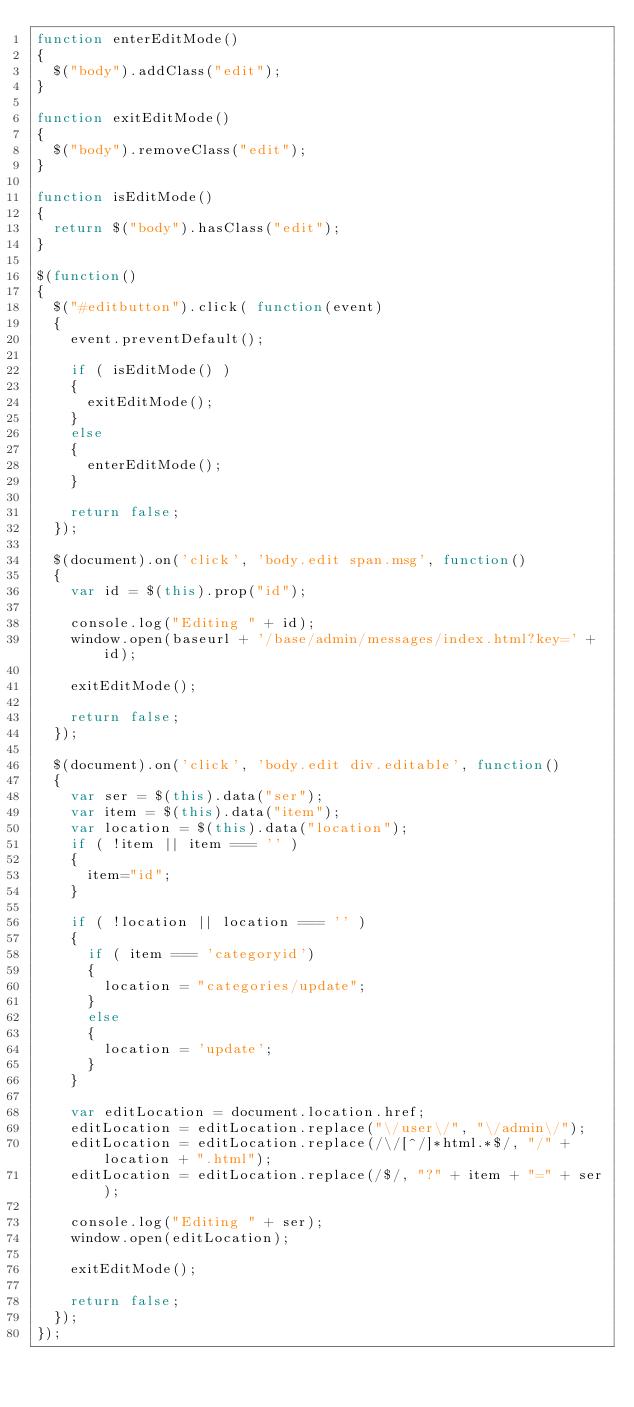<code> <loc_0><loc_0><loc_500><loc_500><_JavaScript_>function enterEditMode()
{
	$("body").addClass("edit");
}

function exitEditMode()
{
	$("body").removeClass("edit");
}

function isEditMode()
{
	return $("body").hasClass("edit");
}

$(function()
{
	$("#editbutton").click( function(event)
	{
		event.preventDefault();

		if ( isEditMode() )
		{
			exitEditMode();
		}
		else
		{
			enterEditMode();
		}

		return false;
	});

	$(document).on('click', 'body.edit span.msg', function()
	{
		var id = $(this).prop("id");

		console.log("Editing " + id);
		window.open(baseurl + '/base/admin/messages/index.html?key=' + id);

		exitEditMode();

		return false;
	});

	$(document).on('click', 'body.edit div.editable', function()
	{
		var ser = $(this).data("ser");
		var item = $(this).data("item");
		var location = $(this).data("location");
		if ( !item || item === '' )
		{
			item="id";
		}

		if ( !location || location === '' )
		{
			if ( item === 'categoryid')
			{
				location = "categories/update";
			}
			else
			{
				location = 'update';
			}
		}

		var editLocation = document.location.href;
		editLocation = editLocation.replace("\/user\/", "\/admin\/");
		editLocation = editLocation.replace(/\/[^/]*html.*$/, "/" + location + ".html");
		editLocation = editLocation.replace(/$/, "?" + item + "=" + ser);

		console.log("Editing " + ser);
		window.open(editLocation);

		exitEditMode();

		return false;
	});
});</code> 